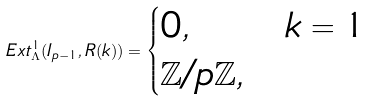Convert formula to latex. <formula><loc_0><loc_0><loc_500><loc_500>E x t ^ { 1 } _ { \Lambda } ( I _ { p - 1 } , R ( k ) ) = \begin{cases} 0 , & k = 1 \\ \mathbb { Z } / p \mathbb { Z } , & \end{cases}</formula> 